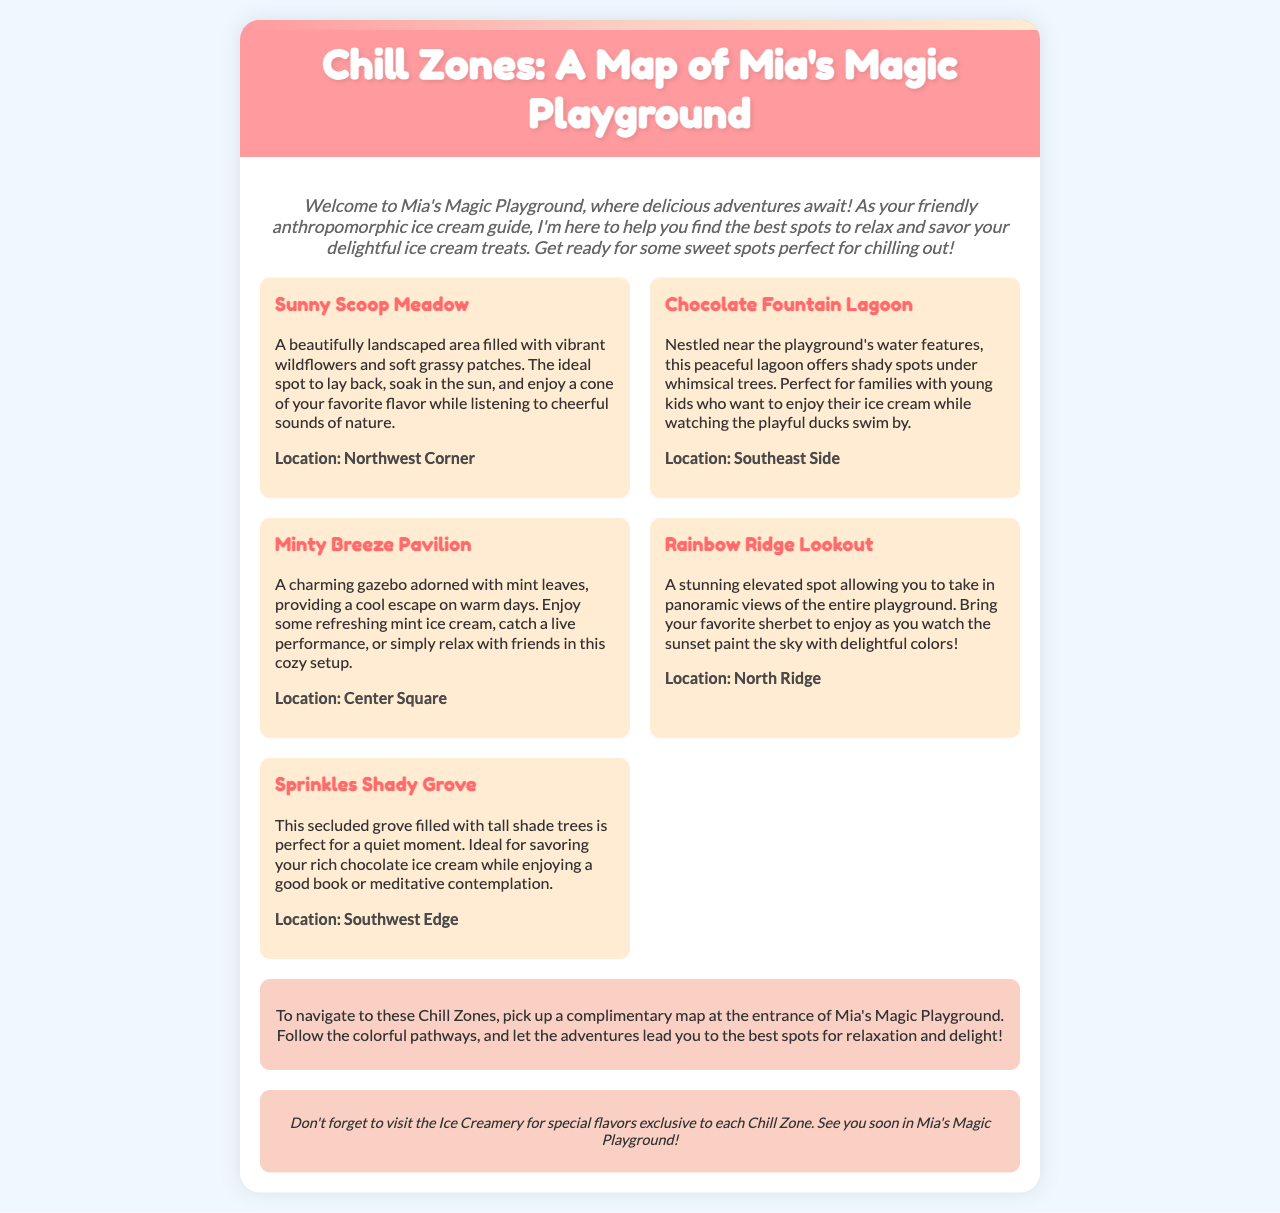what is the title of the brochure? The title is displayed prominently at the top of the document, indicating the focus on relaxation spots in Mia's Magic Playground.
Answer: Chill Zones: A Map of Mia's Magic Playground how many Chill Zones are listed? There are five distinct Chill Zones mentioned in the document for visitors to enjoy.
Answer: Five where is the Sunny Scoop Meadow located? The location of the Sunny Scoop Meadow is specified in the text, describing its position within the playground.
Answer: Northwest Corner which Chill Zone is described as having a gazebo? The description of one of the zones includes details about a charming gazebo, indicating its unique feature.
Answer: Minty Breeze Pavilion what is recommended for visitors to pick up at the entrance? The brochure advises visitors to look for a specific item at the entrance to aid in navigating the playground's Chill Zones.
Answer: Complimentary map which zone is ideal for families with young kids? A particular Chill Zone is highlighted for its suitability for families, referencing a nearby feature that makes it enjoyable for them.
Answer: Chocolate Fountain Lagoon what type of ice cream is suggested for Rainbow Ridge Lookout? The document mentions a specific flavor associated with the viewing experience at this elevated location in the playground.
Answer: Sherbet what should visitors not forget to visit? The brochure provides a recommendation for a location that specializes in unique flavors relevant to the Chill Zones.
Answer: Ice Creamery 